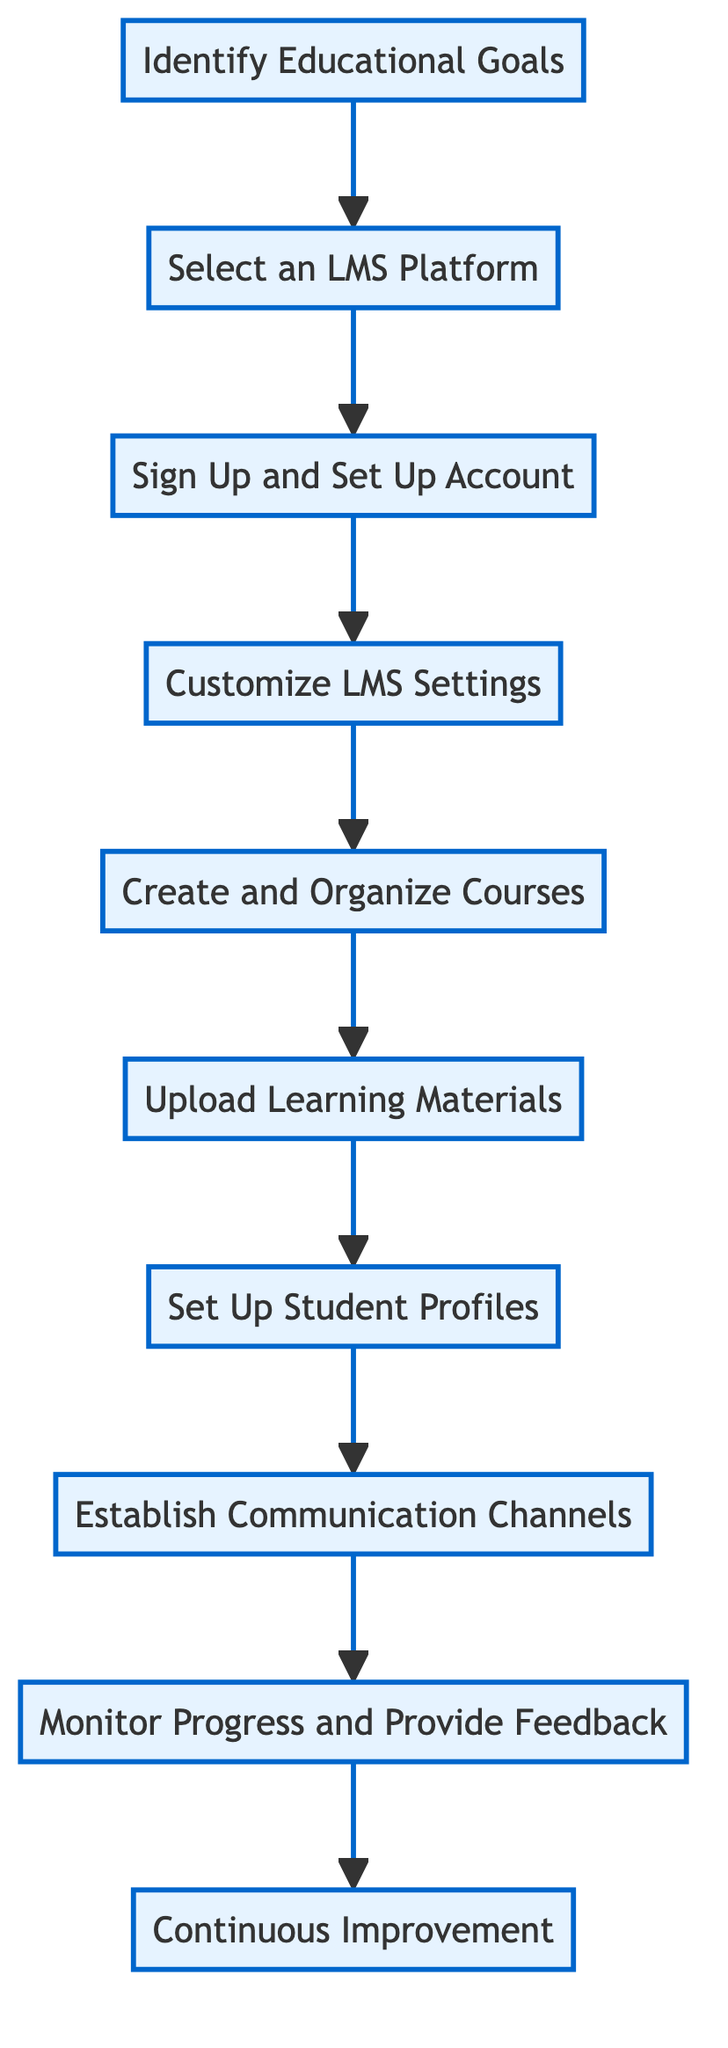What is the first step in the setup process? The first step in the flow chart is labeled "Identify Educational Goals." This is the topmost node in the diagram.
Answer: Identify Educational Goals How many steps are there in total? Counting all of the steps from "Identify Educational Goals" to "Continuous Improvement," there are ten distinct steps in the flow chart.
Answer: 10 What action follows "Customize LMS Settings"? After "Customize LMS Settings," the next action in the flow is "Create and Organize Courses," which comes directly after it as indicated by the arrow.
Answer: Create and Organize Courses What is the last action in the process? The last action shown in the flow chart is "Continuous Improvement," which is located at the bottom of the diagram. This final step signifies ongoing adjustments in the homeschooling process.
Answer: Continuous Improvement Which steps involve setting up accounts or profiles? The steps involving account creation are "Sign Up and Set Up Account" and "Set Up Student Profiles." These steps address initial account registration and assigning students to courses, respectively.
Answer: Sign Up and Set Up Account, Set Up Student Profiles What action is required after uploading learning materials? Once materials have been uploaded, the next action is to "Set Up Student Profiles," suggesting that after content is added, accounts for students must be created or configured.
Answer: Set Up Student Profiles Which two actions are directly connected following "Establish Communication Channels"? Following "Establish Communication Channels," the next action connected is "Monitor Progress and Provide Feedback." This connection indicates the flow from establishing communication tools to using them for tracking progress.
Answer: Monitor Progress and Provide Feedback What is the primary focus of the second step? The second step, "Select an LMS Platform," focuses on choosing a suitable Learning Management System that fits the user's needs for homeschooling, emphasizing the selection of technology.
Answer: Select an LMS Platform How does "Customize LMS Settings" relate to the previous action? "Customize LMS Settings" follows directly after "Sign Up and Set Up Account," indicating that these settings can only be effectively configured after the initial account has been created.
Answer: Sign Up and Set Up Account 